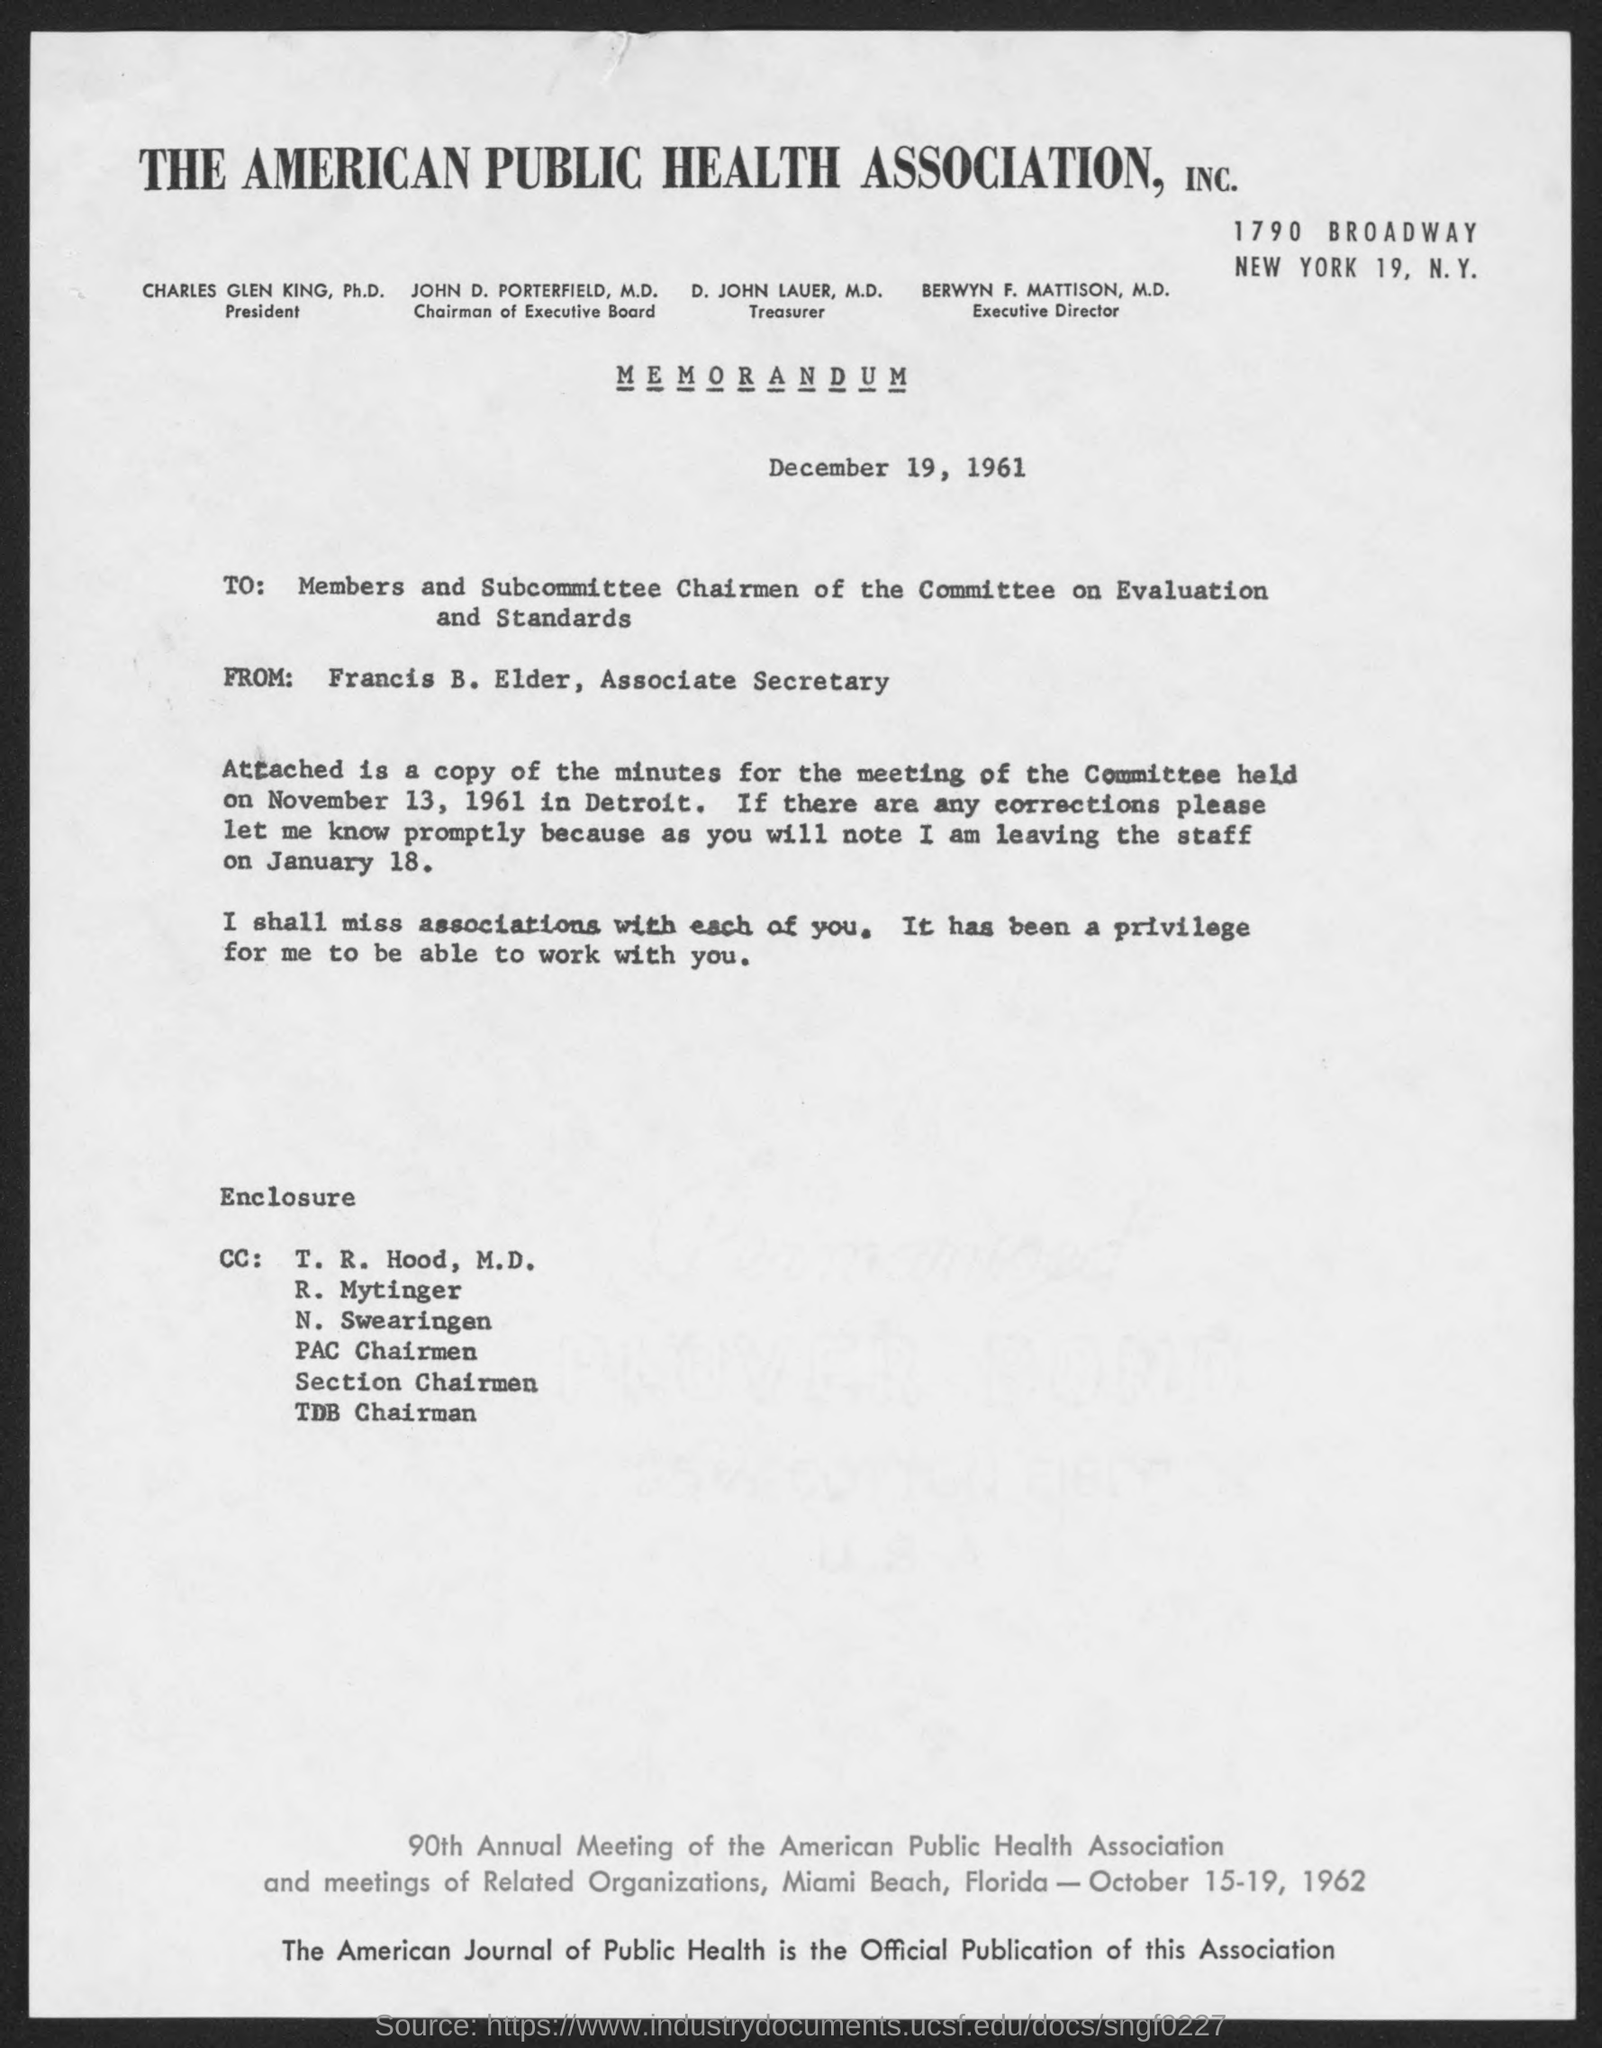Indicate a few pertinent items in this graphic. John D. Porterfield is the chairman of the Executive Board of The American Public Health Association, Inc. The Executive Director of The American Public Health Association, Inc. is Berwyn F. Mattison, M.D. The Treasurer of The American Public Health Association, Inc. is D. John Lauer. The memorandum was dated December 19, 1961. The enclosed copy of minutes of meeting is relevant to November 13, 1961. 